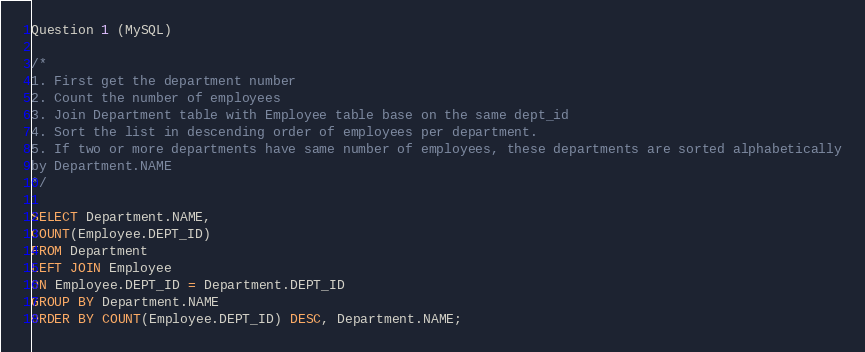Convert code to text. <code><loc_0><loc_0><loc_500><loc_500><_SQL_>Question 1 (MySQL) 

/*
1. First get the department number
2. Count the number of employees
3. Join Department table with Employee table base on the same dept_id
4. Sort the list in descending order of employees per department. 
5. If two or more departments have same number of employees, these departments are sorted alphabetically
by Department.NAME
*/

SELECT Department.NAME,
COUNT(Employee.DEPT_ID)
FROM Department
LEFT JOIN Employee
ON Employee.DEPT_ID = Department.DEPT_ID 
GROUP BY Department.NAME 
ORDER BY COUNT(Employee.DEPT_ID) DESC, Department.NAME;
</code> 